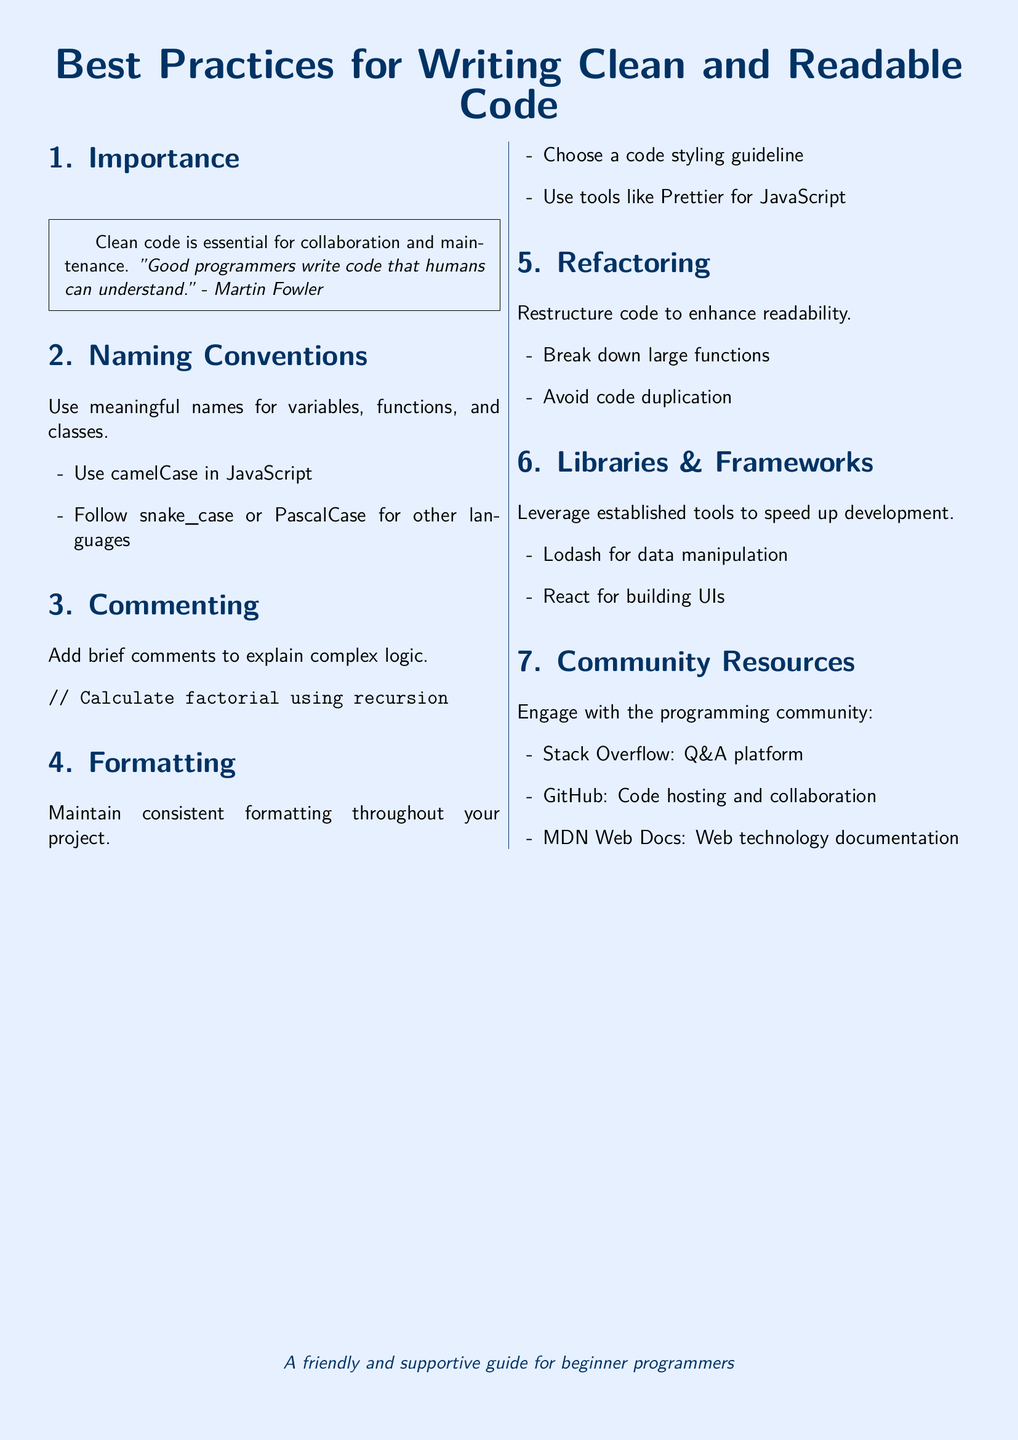What is the purpose of clean code? The document states that clean code is essential for collaboration and maintenance.
Answer: Collaboration and maintenance What does Martin Fowler say about good programmers? The document includes a quote from Martin Fowler about how good programmers write understandable code.
Answer: Write code that humans can understand What naming convention is recommended for JavaScript? The document specifies camelCase as the naming convention for JavaScript.
Answer: camelCase What tool is suggested for JavaScript formatting? The document mentions using Prettier for formatting JavaScript code.
Answer: Prettier What is advised regarding large functions? The document recommends breaking down large functions to enhance readability.
Answer: Break down large functions Which library is suggested for data manipulation? The document suggests using Lodash for data manipulation.
Answer: Lodash What is the main aim of refactoring? The document states that the goal of refactoring is to enhance readability.
Answer: Enhance readability What platform is mentioned for community engagement? The document lists Stack Overflow as a platform for engaging with the programming community.
Answer: Stack Overflow What documentation resource is specifically mentioned in the document? The document identifies MDN Web Docs as a web technology documentation resource.
Answer: MDN Web Docs 